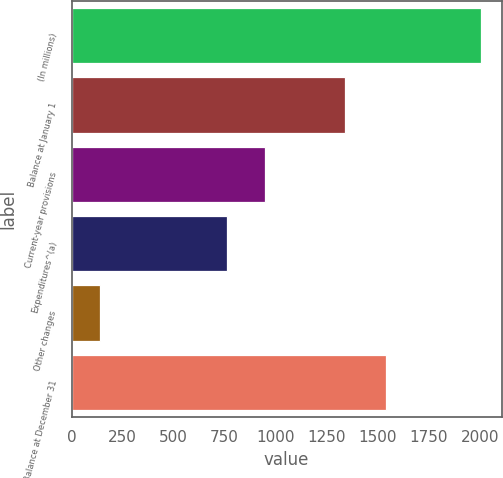Convert chart to OTSL. <chart><loc_0><loc_0><loc_500><loc_500><bar_chart><fcel>(In millions)<fcel>Balance at January 1<fcel>Current-year provisions<fcel>Expenditures^(a)<fcel>Other changes<fcel>Balance at December 31<nl><fcel>2007<fcel>1339<fcel>949.9<fcel>763<fcel>138<fcel>1541<nl></chart> 